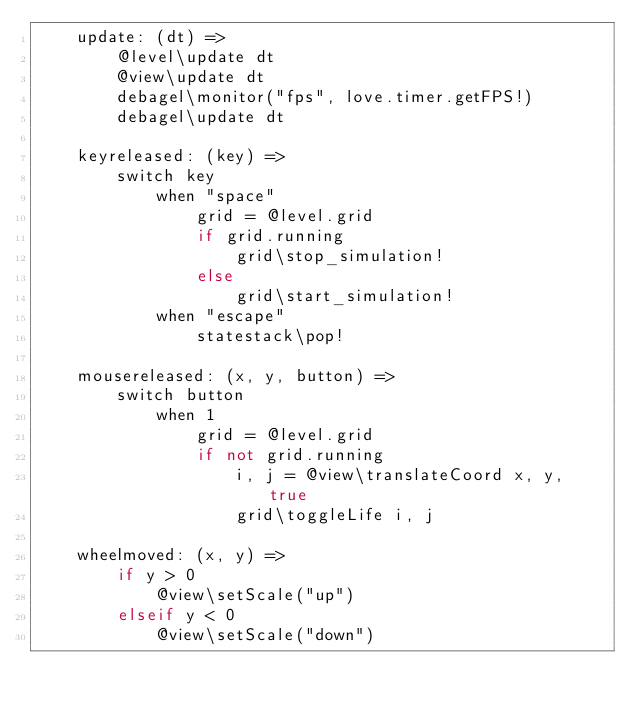<code> <loc_0><loc_0><loc_500><loc_500><_MoonScript_>    update: (dt) =>
        @level\update dt
        @view\update dt
        debagel\monitor("fps", love.timer.getFPS!)
        debagel\update dt

    keyreleased: (key) =>
        switch key
            when "space"
                grid = @level.grid
                if grid.running
                    grid\stop_simulation!
                else
                    grid\start_simulation!
            when "escape"
                statestack\pop!

    mousereleased: (x, y, button) =>
        switch button
            when 1
                grid = @level.grid
                if not grid.running
                    i, j = @view\translateCoord x, y, true
                    grid\toggleLife i, j

    wheelmoved: (x, y) =>
        if y > 0
            @view\setScale("up")
        elseif y < 0
            @view\setScale("down")
</code> 